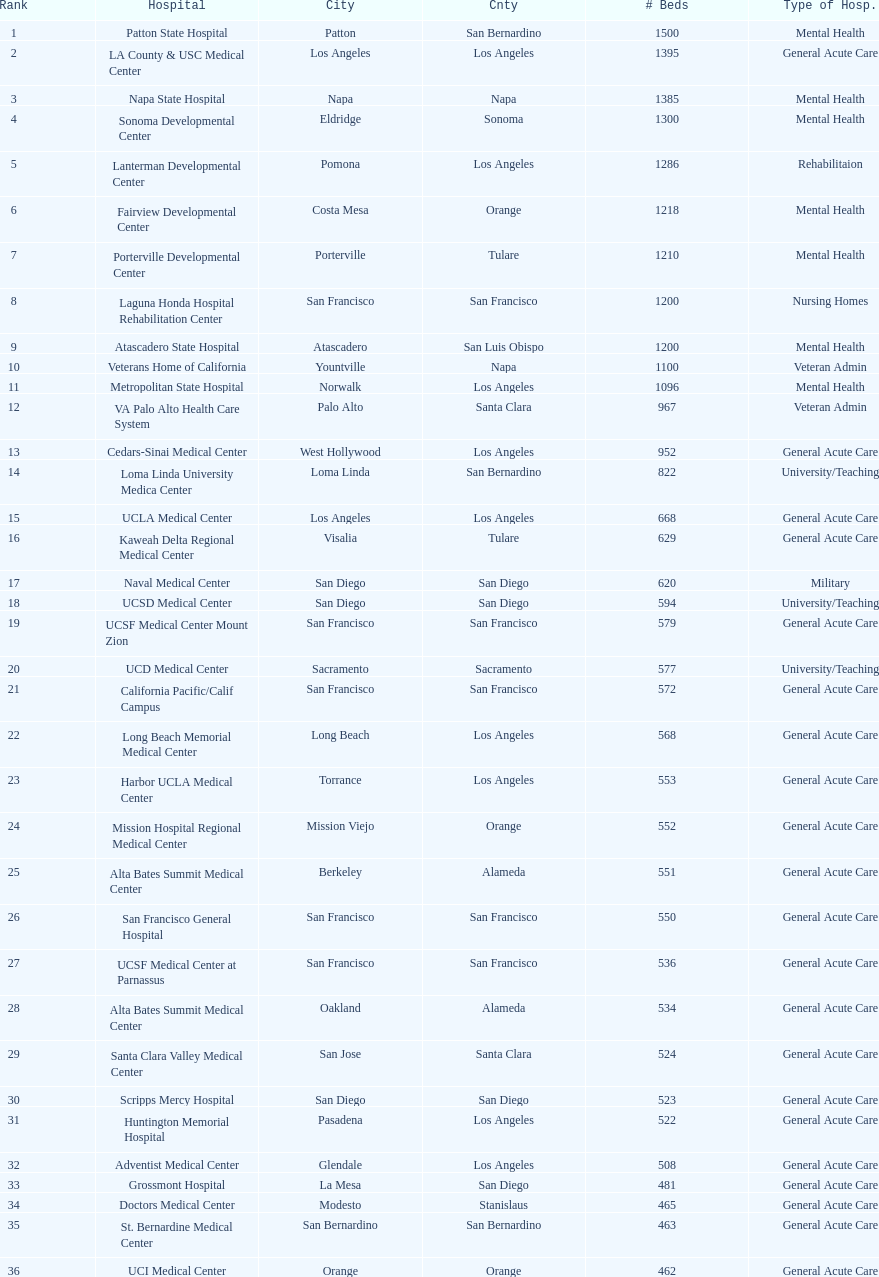How many hospitals have at least 1,000 beds? 11. 